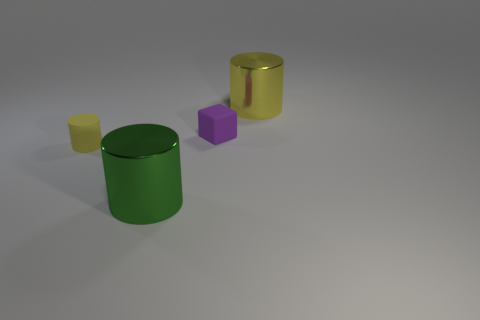What number of other things are the same color as the tiny matte block?
Provide a short and direct response. 0. Is there any other thing that has the same size as the green cylinder?
Keep it short and to the point. Yes. What number of other objects are there of the same shape as the small purple rubber thing?
Your answer should be very brief. 0. Do the yellow matte cylinder and the green shiny thing have the same size?
Your answer should be very brief. No. Are there any tiny cyan cubes?
Your response must be concise. No. Is there any other thing that has the same material as the green object?
Provide a short and direct response. Yes. Are there any large blocks that have the same material as the big green object?
Give a very brief answer. No. There is a green thing that is the same size as the yellow shiny cylinder; what is its material?
Give a very brief answer. Metal. How many other yellow things are the same shape as the small yellow thing?
Ensure brevity in your answer.  1. What is the size of the object that is the same material as the tiny purple cube?
Ensure brevity in your answer.  Small. 